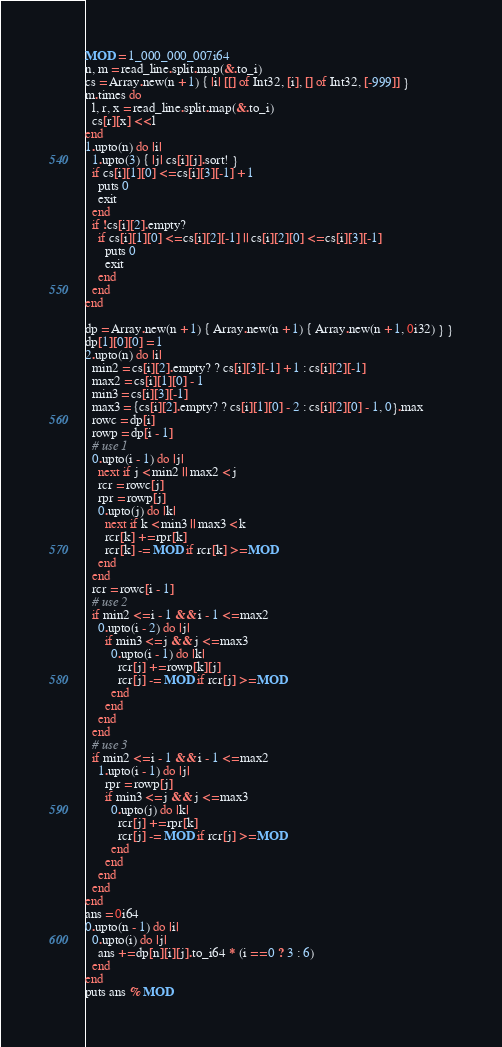<code> <loc_0><loc_0><loc_500><loc_500><_Crystal_>MOD = 1_000_000_007i64
n, m = read_line.split.map(&.to_i)
cs = Array.new(n + 1) { |i| [[] of Int32, [i], [] of Int32, [-999]] }
m.times do
  l, r, x = read_line.split.map(&.to_i)
  cs[r][x] << l
end
1.upto(n) do |i|
  1.upto(3) { |j| cs[i][j].sort! }
  if cs[i][1][0] <= cs[i][3][-1] + 1
    puts 0
    exit
  end
  if !cs[i][2].empty?
    if cs[i][1][0] <= cs[i][2][-1] || cs[i][2][0] <= cs[i][3][-1]
      puts 0
      exit
    end
  end
end

dp = Array.new(n + 1) { Array.new(n + 1) { Array.new(n + 1, 0i32) } }
dp[1][0][0] = 1
2.upto(n) do |i|
  min2 = cs[i][2].empty? ? cs[i][3][-1] + 1 : cs[i][2][-1]
  max2 = cs[i][1][0] - 1
  min3 = cs[i][3][-1]
  max3 = {cs[i][2].empty? ? cs[i][1][0] - 2 : cs[i][2][0] - 1, 0}.max
  rowc = dp[i]
  rowp = dp[i - 1]
  # use 1
  0.upto(i - 1) do |j|
    next if j < min2 || max2 < j
    rcr = rowc[j]
    rpr = rowp[j]
    0.upto(j) do |k|
      next if k < min3 || max3 < k
      rcr[k] += rpr[k]
      rcr[k] -= MOD if rcr[k] >= MOD
    end
  end
  rcr = rowc[i - 1]
  # use 2
  if min2 <= i - 1 && i - 1 <= max2
    0.upto(i - 2) do |j|
      if min3 <= j && j <= max3
        0.upto(i - 1) do |k|
          rcr[j] += rowp[k][j]
          rcr[j] -= MOD if rcr[j] >= MOD
        end
      end
    end
  end
  # use 3
  if min2 <= i - 1 && i - 1 <= max2
    1.upto(i - 1) do |j|
      rpr = rowp[j]
      if min3 <= j && j <= max3
        0.upto(j) do |k|
          rcr[j] += rpr[k]
          rcr[j] -= MOD if rcr[j] >= MOD
        end
      end
    end
  end
end
ans = 0i64
0.upto(n - 1) do |i|
  0.upto(i) do |j|
    ans += dp[n][i][j].to_i64 * (i == 0 ? 3 : 6)
  end
end
puts ans % MOD
</code> 